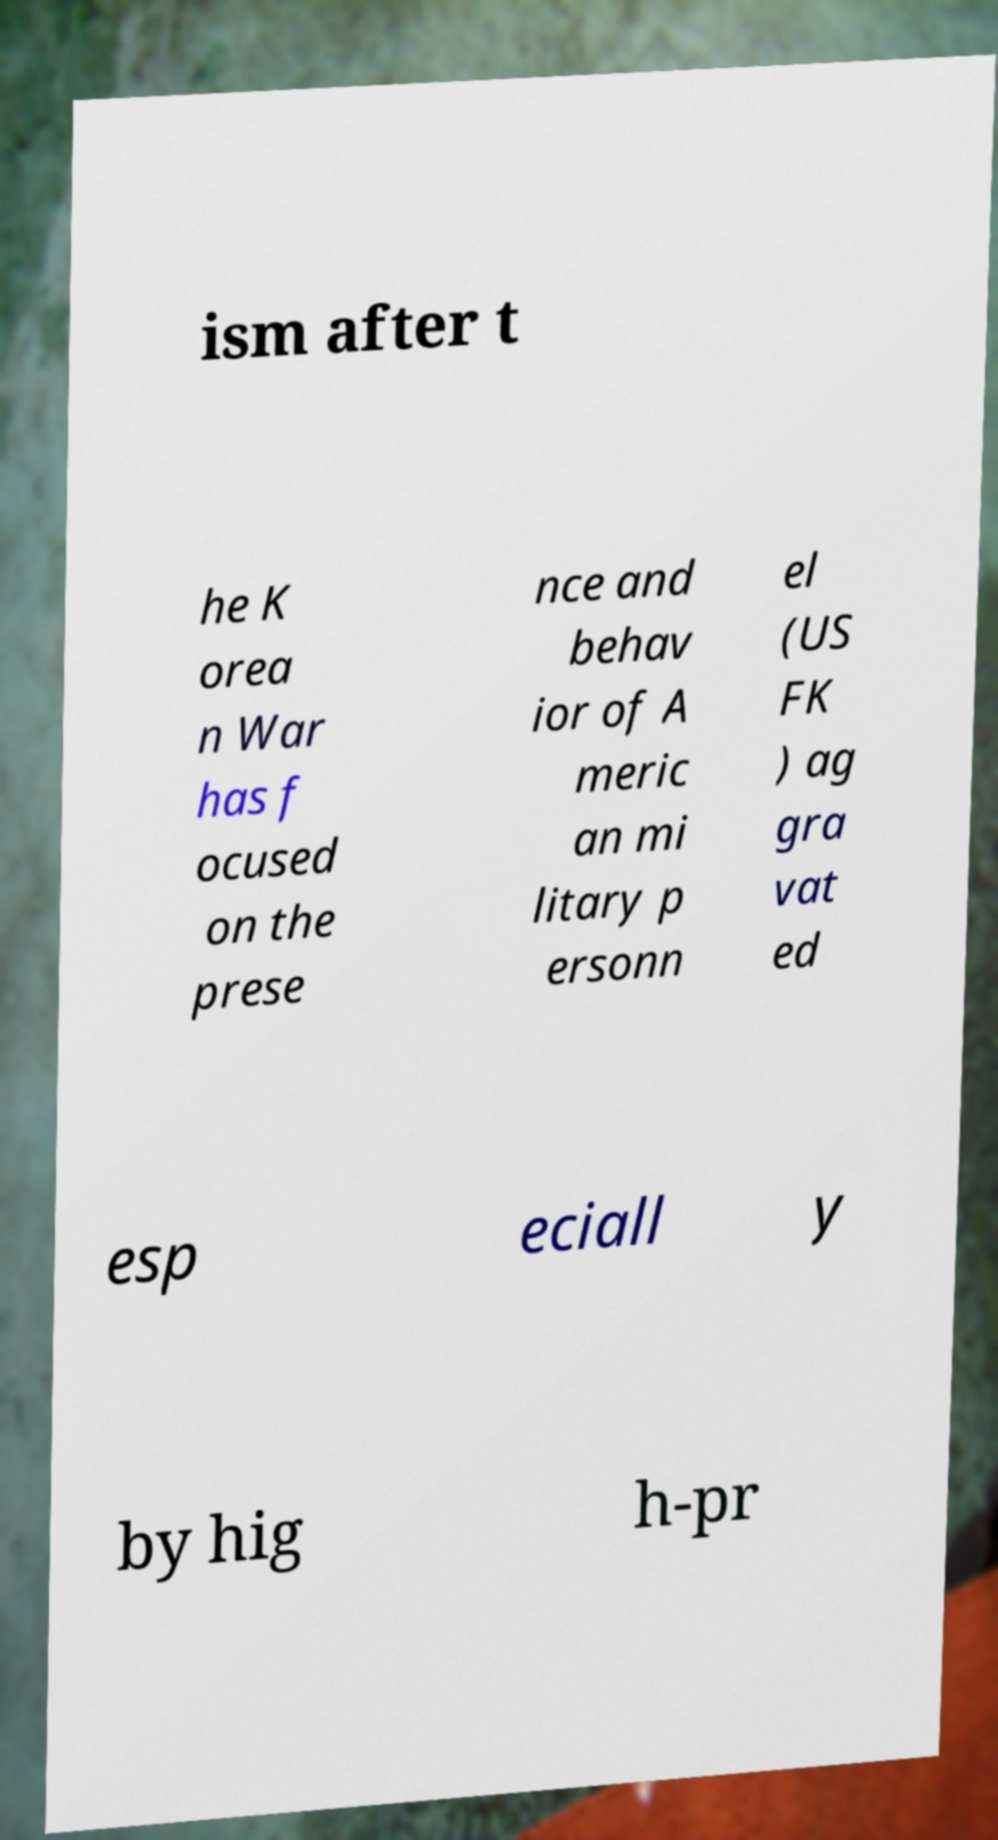For documentation purposes, I need the text within this image transcribed. Could you provide that? ism after t he K orea n War has f ocused on the prese nce and behav ior of A meric an mi litary p ersonn el (US FK ) ag gra vat ed esp eciall y by hig h-pr 